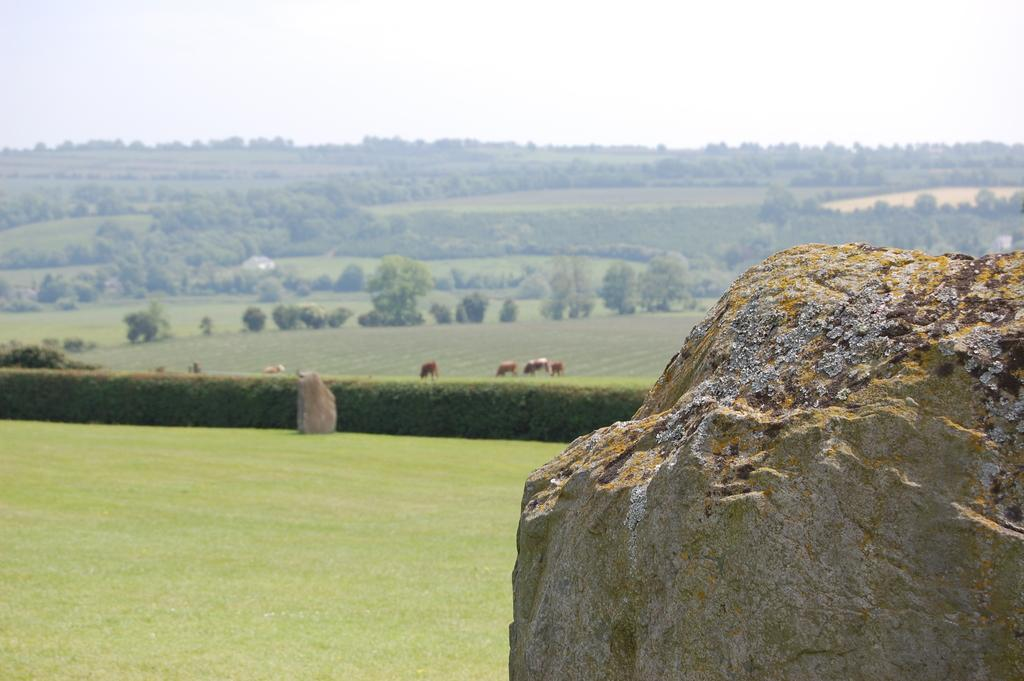What is the main subject in the image? There is a rock in the image. How would you describe the background of the image? The background of the image is blurry. What type of living organisms can be seen in the image? Animals are visible in the image. What type of vegetation is present in the image? Plants, trees, and grass are present in the image. What part of the natural environment is visible in the image? The sky is visible at the top of the image. What type of force is being applied to the rock in the image? There is no force being applied to the rock in the image; it is stationary. Can you see a whip in the image? No, there is no whip present in the image. 